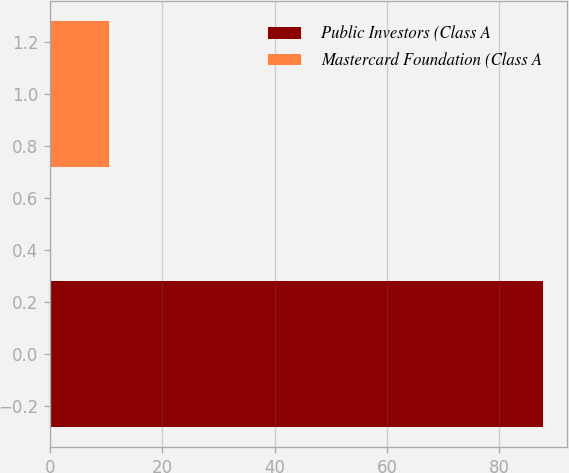Convert chart to OTSL. <chart><loc_0><loc_0><loc_500><loc_500><bar_chart><fcel>Public Investors (Class A<fcel>Mastercard Foundation (Class A<nl><fcel>87.7<fcel>10.5<nl></chart> 